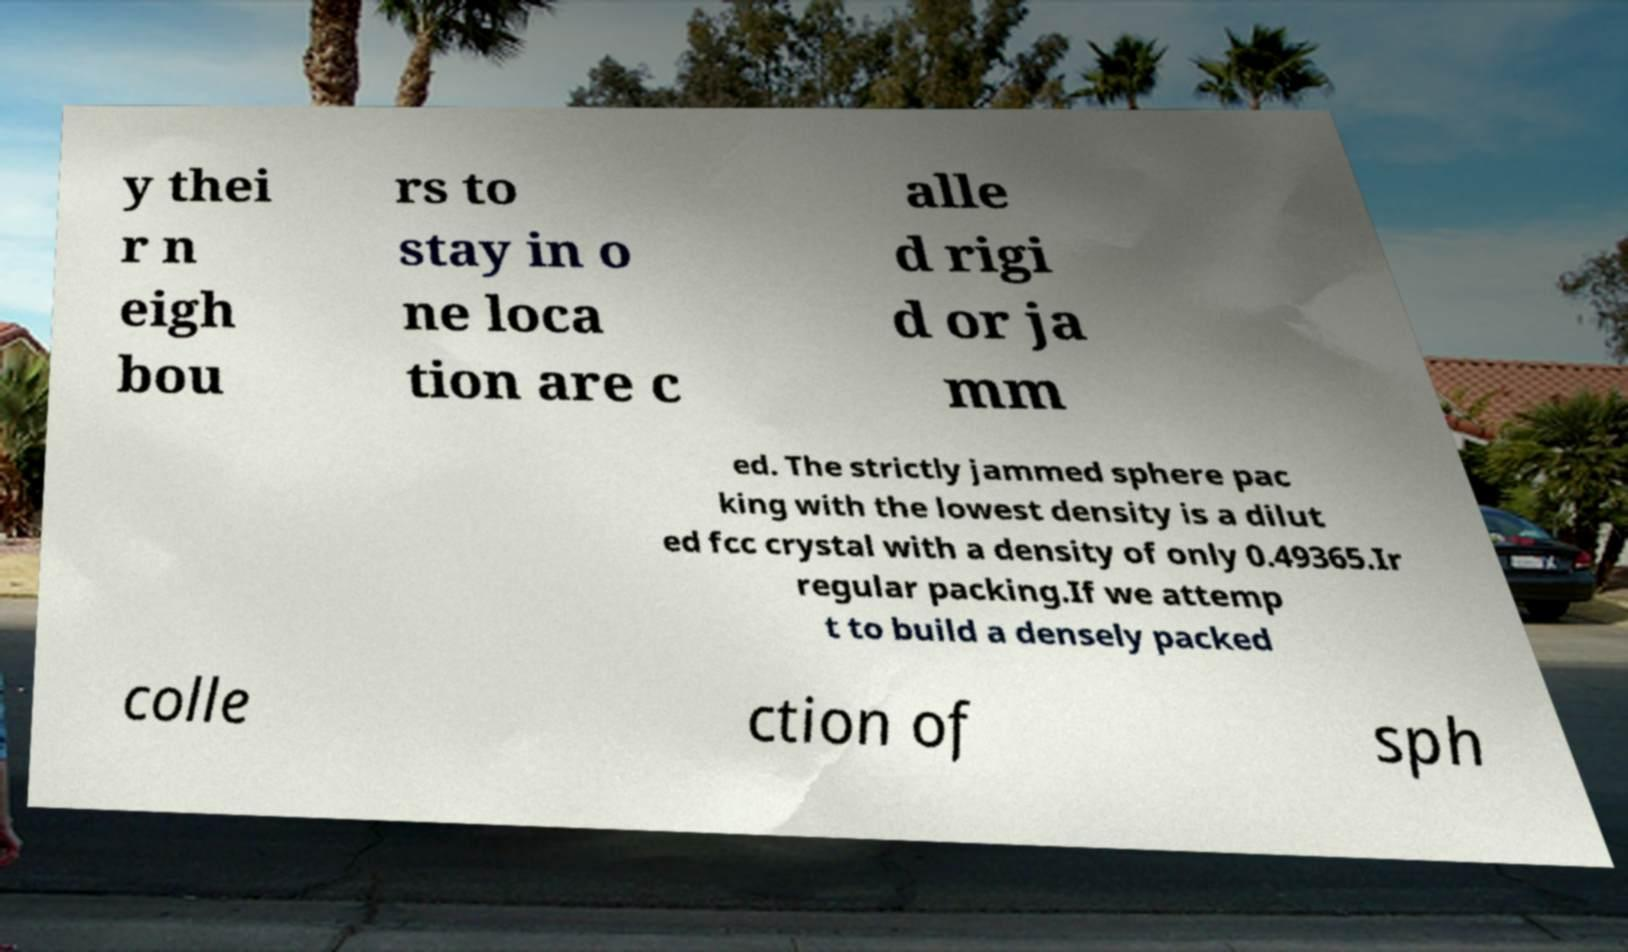There's text embedded in this image that I need extracted. Can you transcribe it verbatim? y thei r n eigh bou rs to stay in o ne loca tion are c alle d rigi d or ja mm ed. The strictly jammed sphere pac king with the lowest density is a dilut ed fcc crystal with a density of only 0.49365.Ir regular packing.If we attemp t to build a densely packed colle ction of sph 